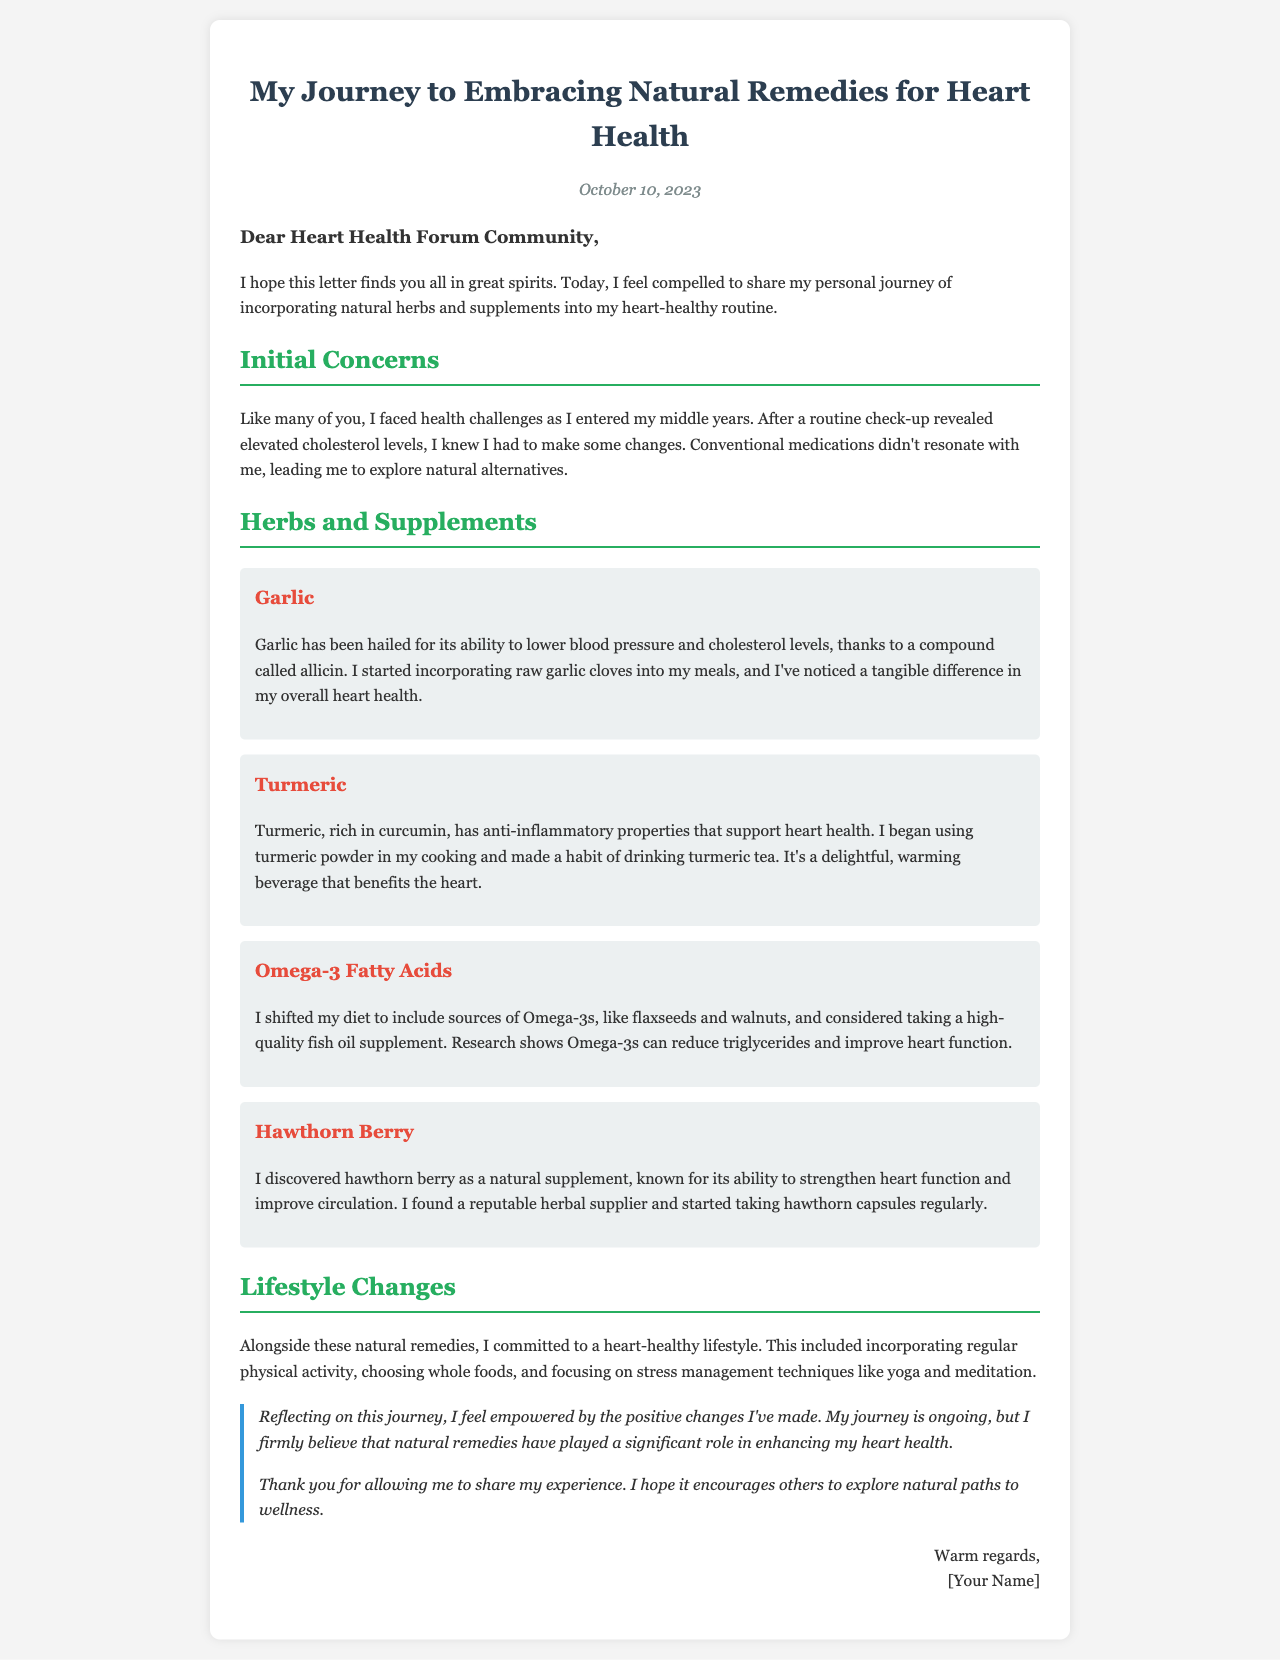What date is the letter written? The date of the letter is specified in the document as "October 10, 2023."
Answer: October 10, 2023 What is the sender's address to the community? The sender addresses the community with the greeting "Dear Heart Health Forum Community."
Answer: Dear Heart Health Forum Community Which herb is noted for lowering blood pressure? The herb mentioned for its ability to lower blood pressure is garlic, specifically due to a compound called allicin.
Answer: Garlic What are the sources of Omega-3s mentioned? The document states that the sender shifted their diet to include flaxseeds and walnuts as sources of Omega-3s.
Answer: Flaxseeds and walnuts What lifestyle changes did the sender commit to? The document mentions that the sender incorporated regular physical activity, whole foods, and stress management techniques.
Answer: Regular physical activity Why did the sender explore natural remedies? The sender explored natural remedies because conventional medications didn't resonate with them after finding elevated cholesterol levels.
Answer: Elevated cholesterol levels Which natural supplement is known for its ability to strengthen heart function? The natural supplement mentioned for strengthening heart function is hawthorn berry.
Answer: Hawthorn berry What benefit does turmeric provide for heart health? Turmeric is noted for its anti-inflammatory properties that support heart health.
Answer: Anti-inflammatory properties In what format does the sender conclude the letter? The sender concludes the letter with "Warm regards," followed by a placeholder for their name.
Answer: Warm regards 